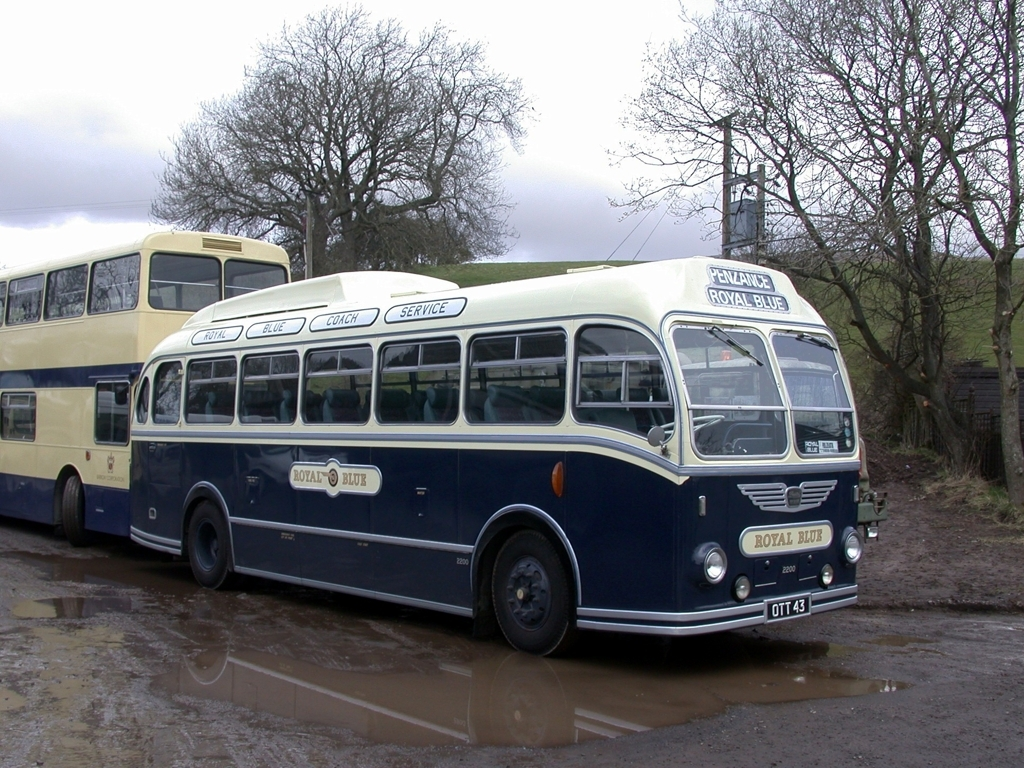What does the signage on the bus indicate about its service? The signage on the bus displays 'Royal Blue Coach Service' and destination placards reading 'Cornwall' and 'Penzance.' This reveals that the bus was part of a coach service, possibly offering intercity or regional travel, connecting passengers to various locales. The specific mention of Cornwall and Penzance, which are located in the South-West of England, indicates the regional focus of the service and suggests a snapshot of British transport history. 